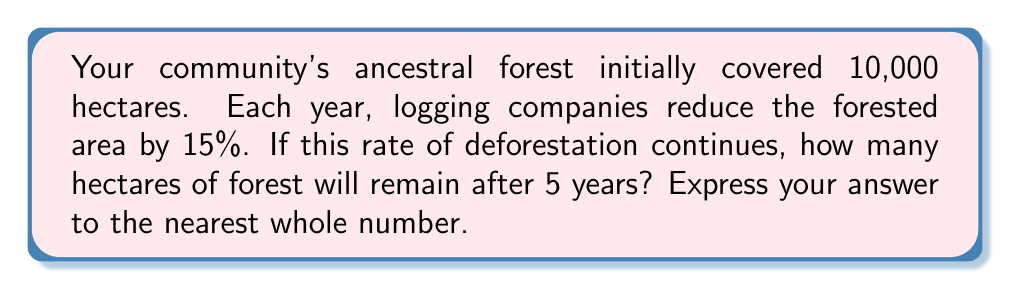Teach me how to tackle this problem. Let's approach this step-by-step using a geometric sequence:

1) The initial area is $a_1 = 10,000$ hectares.

2) Each year, the forest is reduced by 15%, meaning 85% remains. This gives us a common ratio of $r = 0.85$.

3) We want to find the area after 5 years, which is the 6th term in the sequence (as the initial area is the 1st term).

4) The formula for the nth term of a geometric sequence is:

   $a_n = a_1 \cdot r^{n-1}$

5) Plugging in our values:

   $a_6 = 10,000 \cdot 0.85^{6-1}$
   $a_6 = 10,000 \cdot 0.85^5$

6) Calculate:

   $a_6 = 10,000 \cdot 0.4437053462$
   $a_6 = 4,437.053462$

7) Rounding to the nearest whole number:

   $a_6 \approx 4,437$ hectares
Answer: 4,437 hectares 